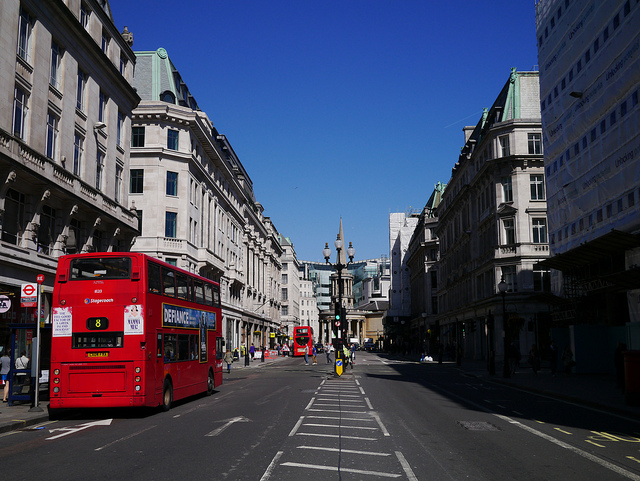Please transcribe the text information in this image. 8 